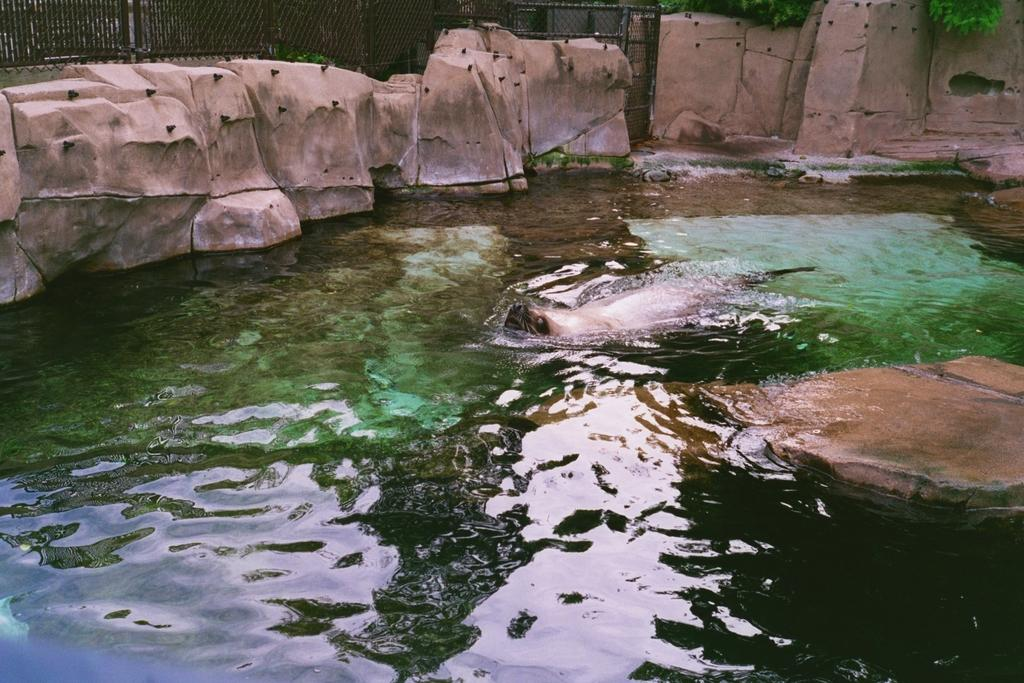What is the main subject in the center of the image? There is water in the center of the image. What type of creature can be seen in the water? There is an aquatic animal in the water. What can be seen in the background of the image? There are rocks and a fence in the background of the image. What type of vegetation is visible in the image? Leaves are visible in the image. What book is the aquatic animal reading in the image? There is no book or reading activity present in the image; it features an aquatic animal in the water. What emotion does the aquatic animal express in the image? The image does not depict any emotions or expressions of regret from the aquatic animal. 